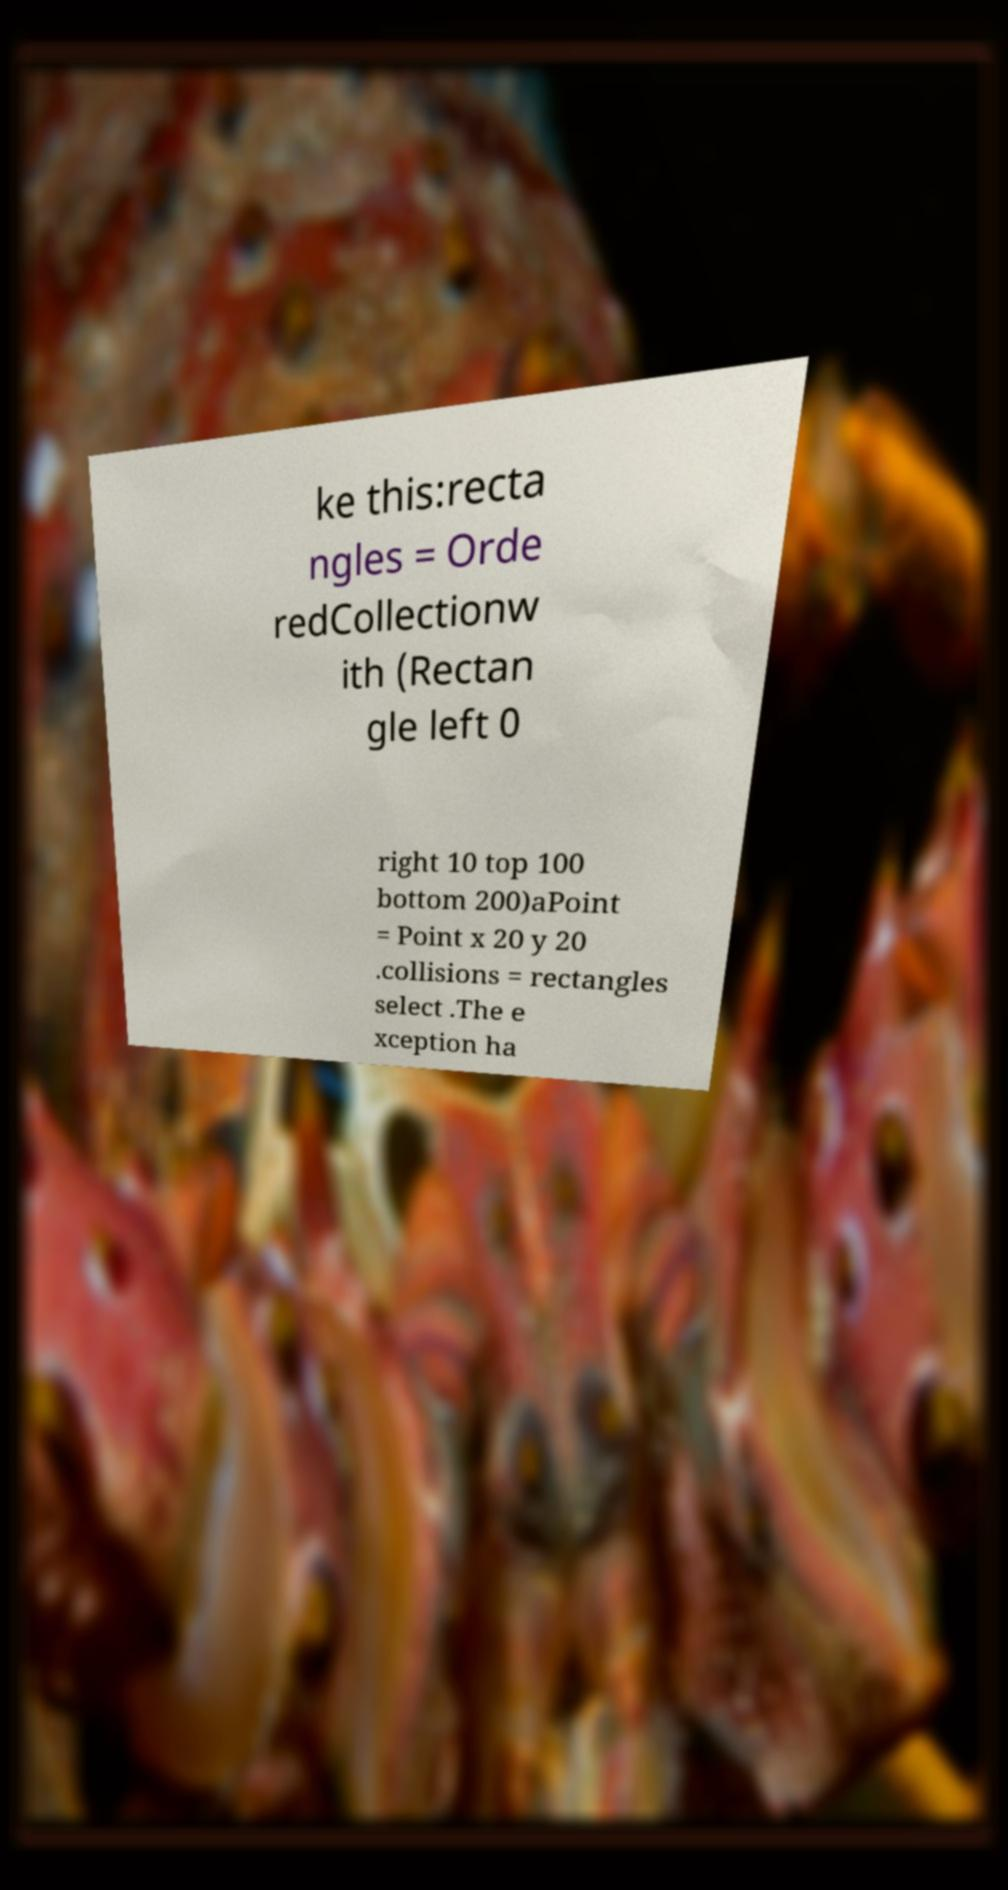There's text embedded in this image that I need extracted. Can you transcribe it verbatim? ke this:recta ngles = Orde redCollectionw ith (Rectan gle left 0 right 10 top 100 bottom 200)aPoint = Point x 20 y 20 .collisions = rectangles select .The e xception ha 